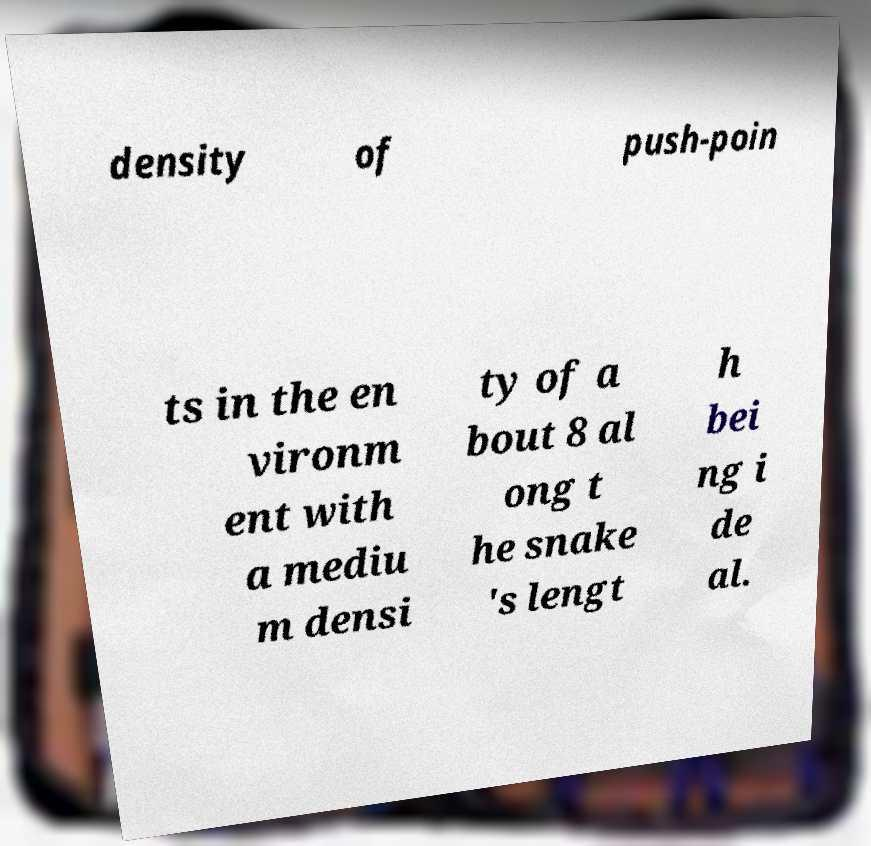Could you assist in decoding the text presented in this image and type it out clearly? density of push-poin ts in the en vironm ent with a mediu m densi ty of a bout 8 al ong t he snake 's lengt h bei ng i de al. 